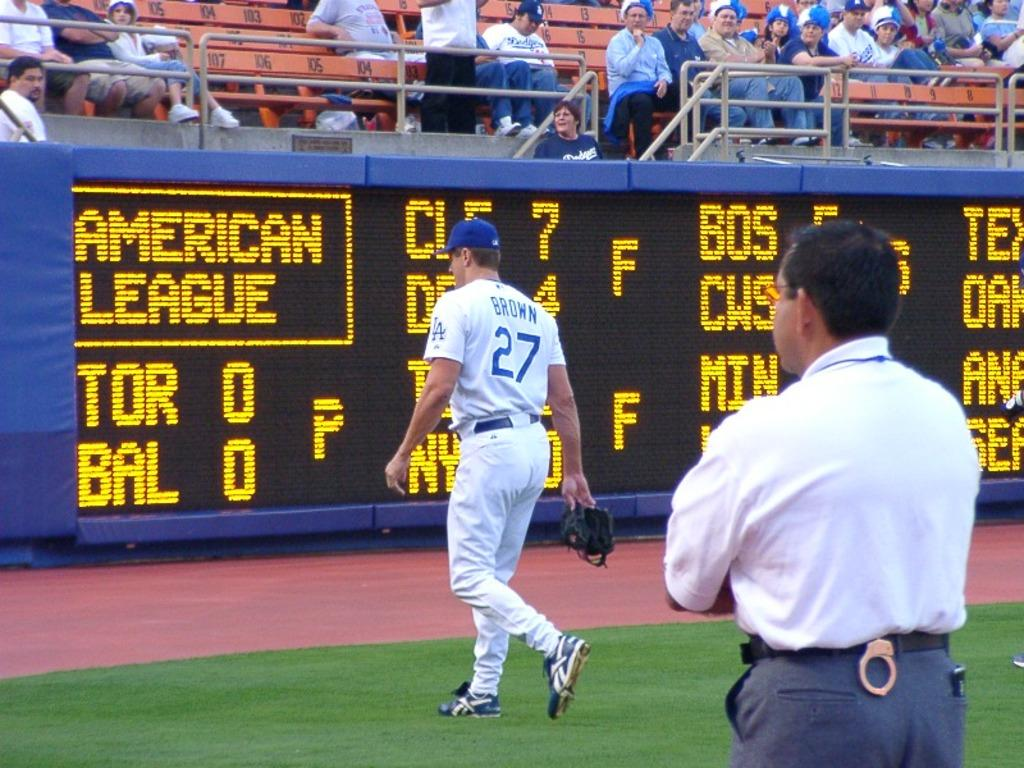<image>
Provide a brief description of the given image. An electronic screen says "American League" in yellow letters. 